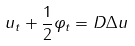<formula> <loc_0><loc_0><loc_500><loc_500>u _ { t } + \frac { 1 } { 2 } \varphi _ { t } = D \Delta { u }</formula> 